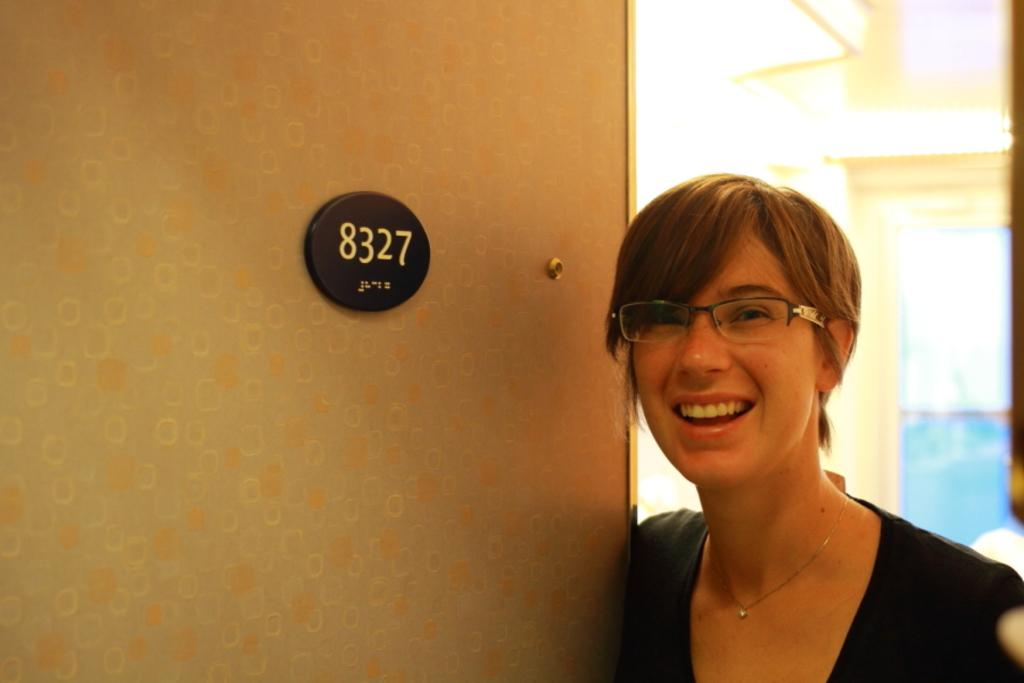Who is present in the image? There is a woman in the image. What is the woman's facial expression? The woman is smiling. What object can be seen in the image besides the woman? There is a number board in the image. How many gloves can be seen floating in the waves in the image? There are no gloves or waves present in the image. 